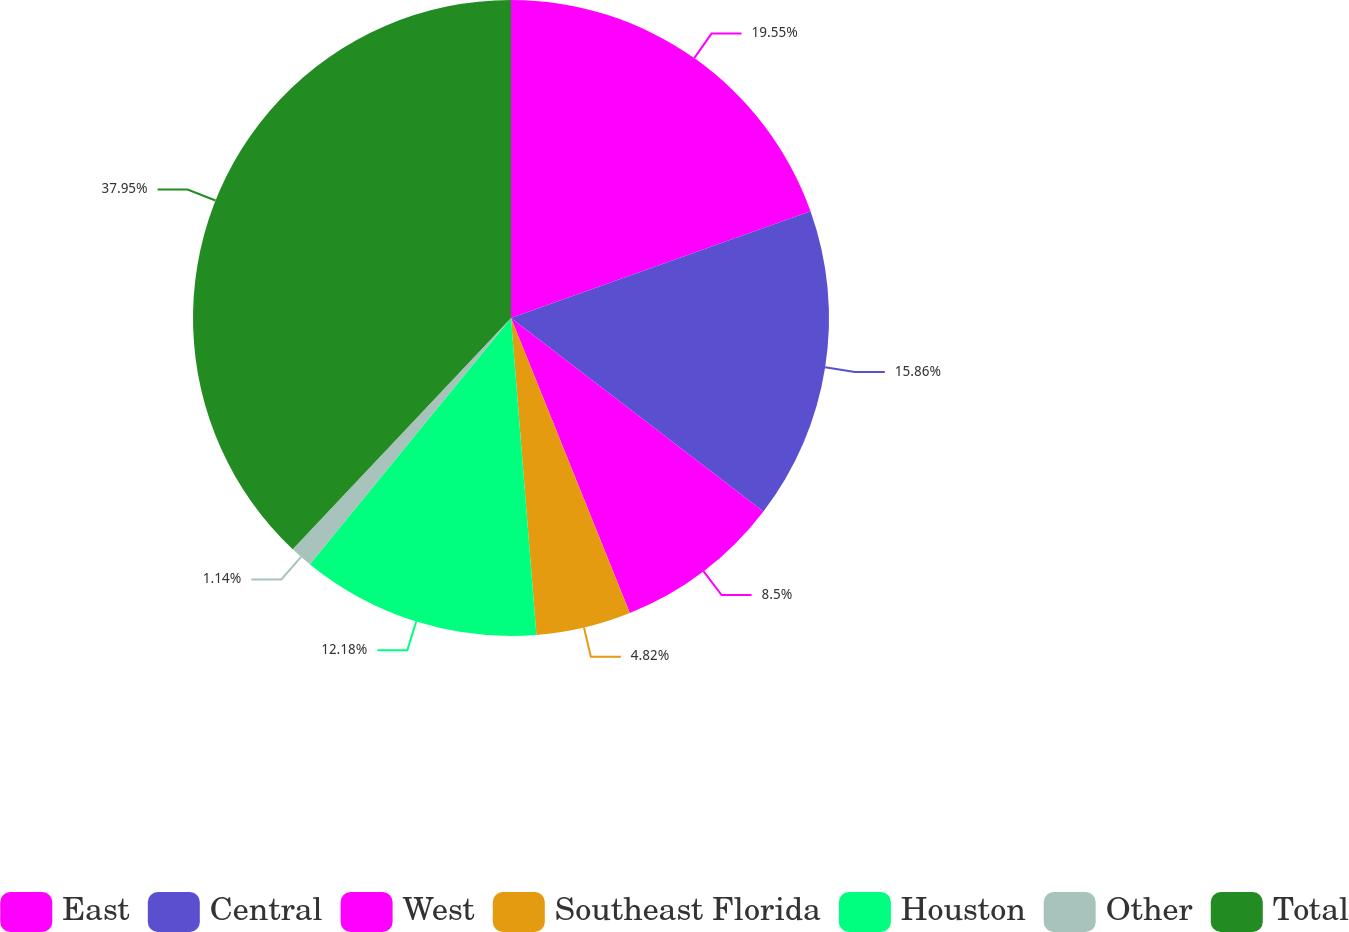<chart> <loc_0><loc_0><loc_500><loc_500><pie_chart><fcel>East<fcel>Central<fcel>West<fcel>Southeast Florida<fcel>Houston<fcel>Other<fcel>Total<nl><fcel>19.55%<fcel>15.86%<fcel>8.5%<fcel>4.82%<fcel>12.18%<fcel>1.14%<fcel>37.96%<nl></chart> 